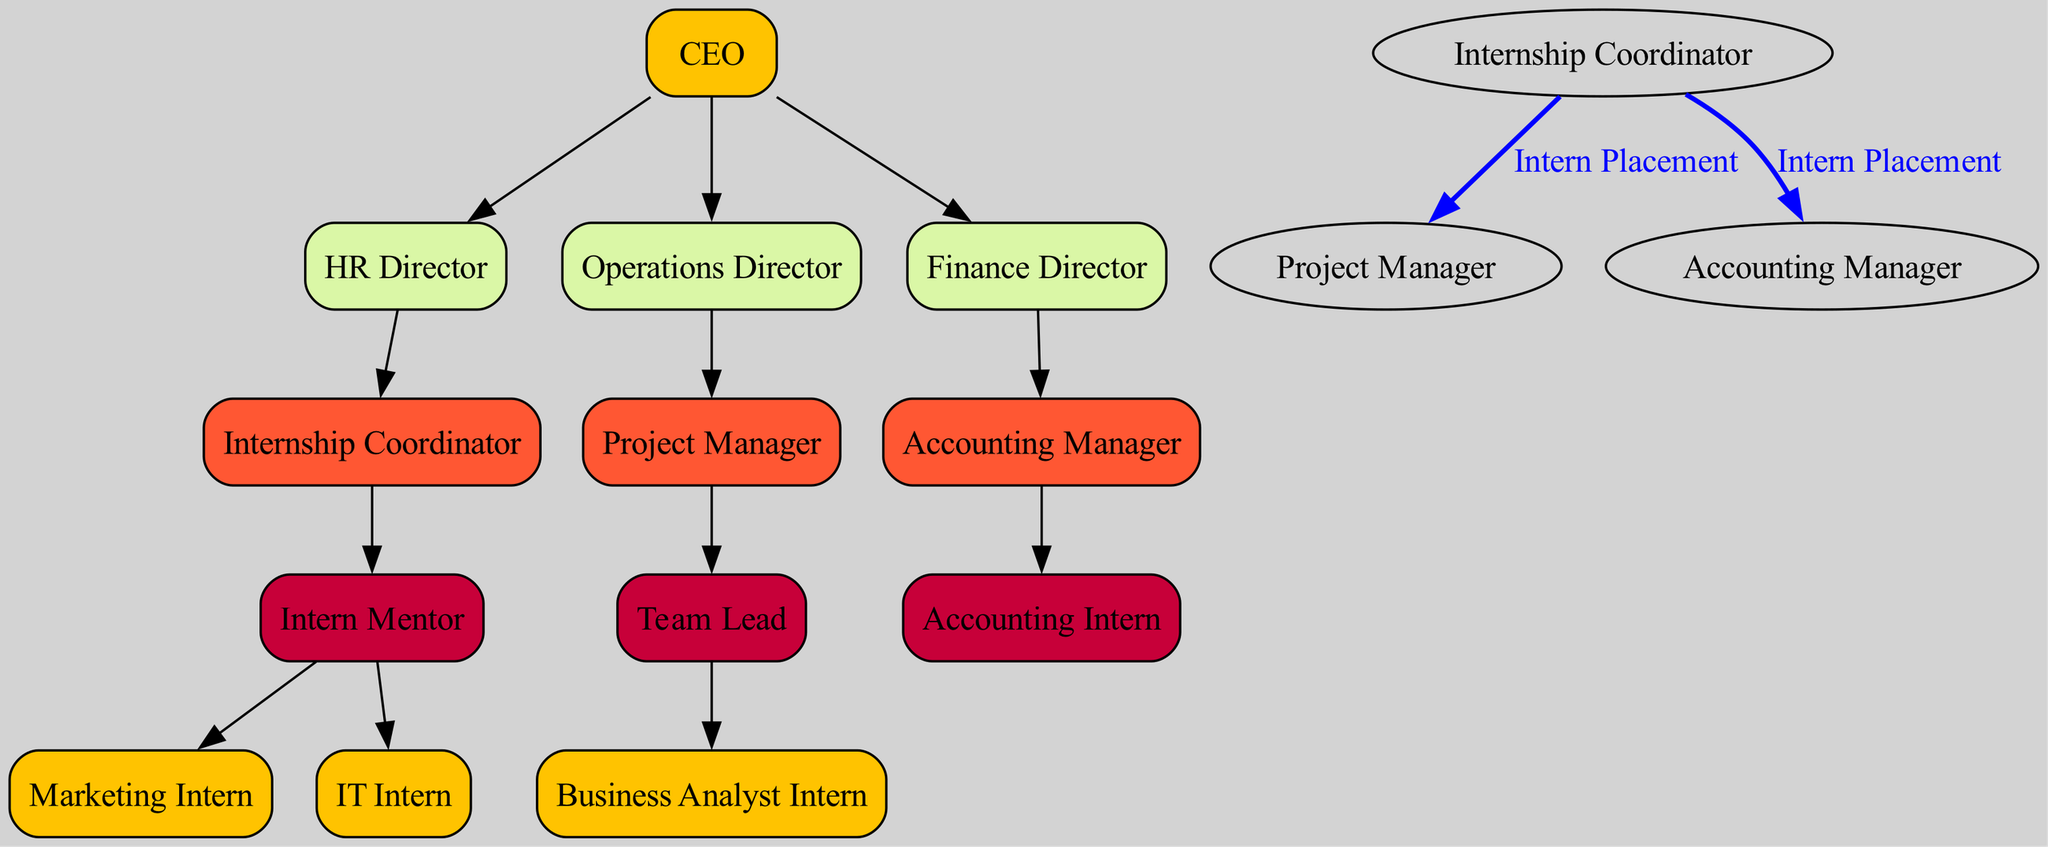What is the highest position in the organizational chart? The diagram shows the top-level node as "CEO," indicating that it is the highest position within the company structure.
Answer: CEO How many intern roles are directly under the Internship Coordinator? The Internship Coordinator is connected to two intern roles: "Marketing Intern" and "IT Intern," making the total two intern roles directly under this position.
Answer: 2 Who supervises the Business Analyst Intern? The diagram illustrates that the Business Analyst Intern is supervised by the "Team Lead," who is a child of the "Project Manager."
Answer: Team Lead What type of connections are shown for intern placement? The diagram specifically labels connections for intern placement between the "Internship Coordinator" and both "Project Manager" and "Accounting Manager," indicating the flow of intern integration within the company.
Answer: Intern Placement Which director is responsible for accounting? The "Finance Director" oversees the accounting side of the organization as detailed in the diagram, where "Accounting Manager" is placed under this directorate.
Answer: Finance Director How many levels are there in the hierarchy from the CEO to the interns? To determine the levels, start from the CEO at the top (first level), then the directors (second level), followed by managers and coordinators (third level), and ultimately the interns at the fourth level. Thus, there are four levels in total from the CEO to the interns.
Answer: 4 What roles are directly linked to the Internship Coordinator? The Internship Coordinator is directly linked to the "Intern Mentor," which in turn includes two intern roles: "Marketing Intern" and "IT Intern," evidencing a direct relationship between the coordinator and these roles.
Answer: Intern Mentor Which intern is associated with the accounting department? The diagram specifies that the "Accounting Intern" falls under the supervision of the "Accounting Manager," indicating this intern's association with the accounting department.
Answer: Accounting Intern What is the label on the connection between Internship Coordinator and Accounting Manager? The connection between the Internship Coordinator and the Accounting Manager is labeled as "Intern Placement," which indicates the purpose of the connection.
Answer: Intern Placement 